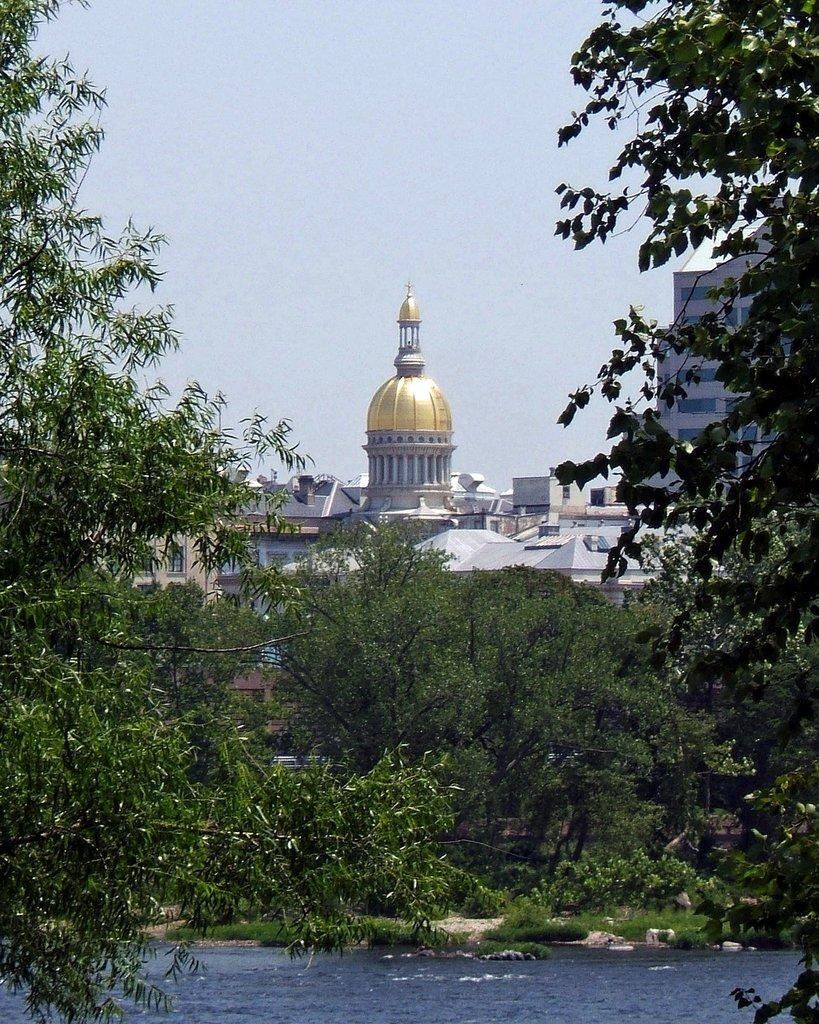What is the primary element visible in the image? There is water in the image. What type of vegetation can be seen in the image? There are trees visible in the image. What type of structures are present in the background of the image? There are buildings in the background of the image. What flavor of bun can be seen floating in the water in the image? There are no buns present in the image, and therefore no flavor can be determined. 